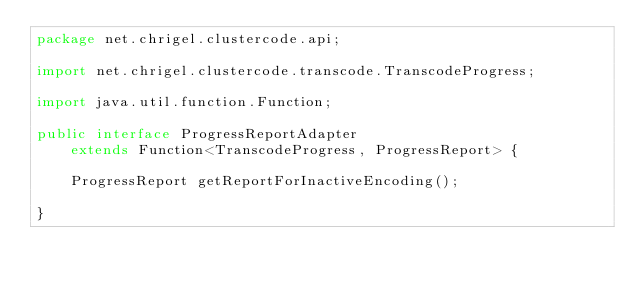Convert code to text. <code><loc_0><loc_0><loc_500><loc_500><_Java_>package net.chrigel.clustercode.api;

import net.chrigel.clustercode.transcode.TranscodeProgress;

import java.util.function.Function;

public interface ProgressReportAdapter
    extends Function<TranscodeProgress, ProgressReport> {

    ProgressReport getReportForInactiveEncoding();

}
</code> 